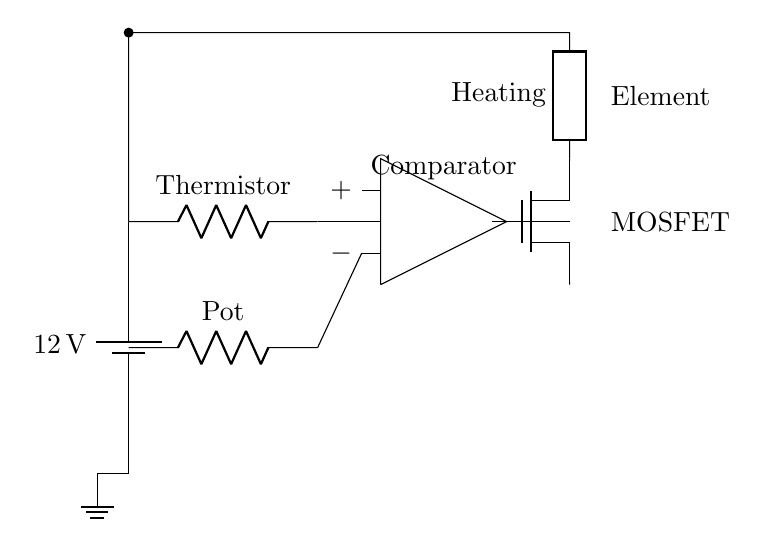What is the voltage of the power supply? The power supply voltage is labeled as 12V in the diagram, which provides the necessary energy for the circuit's operation.
Answer: 12V What type of transistor is used in the circuit? The diagram shows a MOSFET (n-channel MOSFET), which is used for switching the heating element based on the comparator output; seen as labeled in the circuit.
Answer: MOSFET What component provides the reference voltage? The potentiometer (Pot) provides the reference voltage for the comparator, allowing for temperature sensitivity adjustment; this is labeled in the circuit diagram.
Answer: Potentiometer What role does the thermistor play in this circuit? The thermistor detects temperature changes, providing input to the op-amp comparator; its placement indicates it measures the temperature at the desired location and modulates the operation of the circuit accordingly.
Answer: Temperature sensing What is the function of the op-amp in this circuit? The op-amp operates as a comparator, comparing the voltage from the thermistor with the reference voltage to control the MOSFET, thereby regulating the heating element; this is evident from its connections shown in the diagram.
Answer: Comparator How does the heating element receive power? The MOSFET controls the power to the heating element; when the op-amp output signals the MOSFET to switch on, it allows current through to the heating element, shown by the connection from the MOSFET to the heating element in the circuit.
Answer: Through the MOSFET 